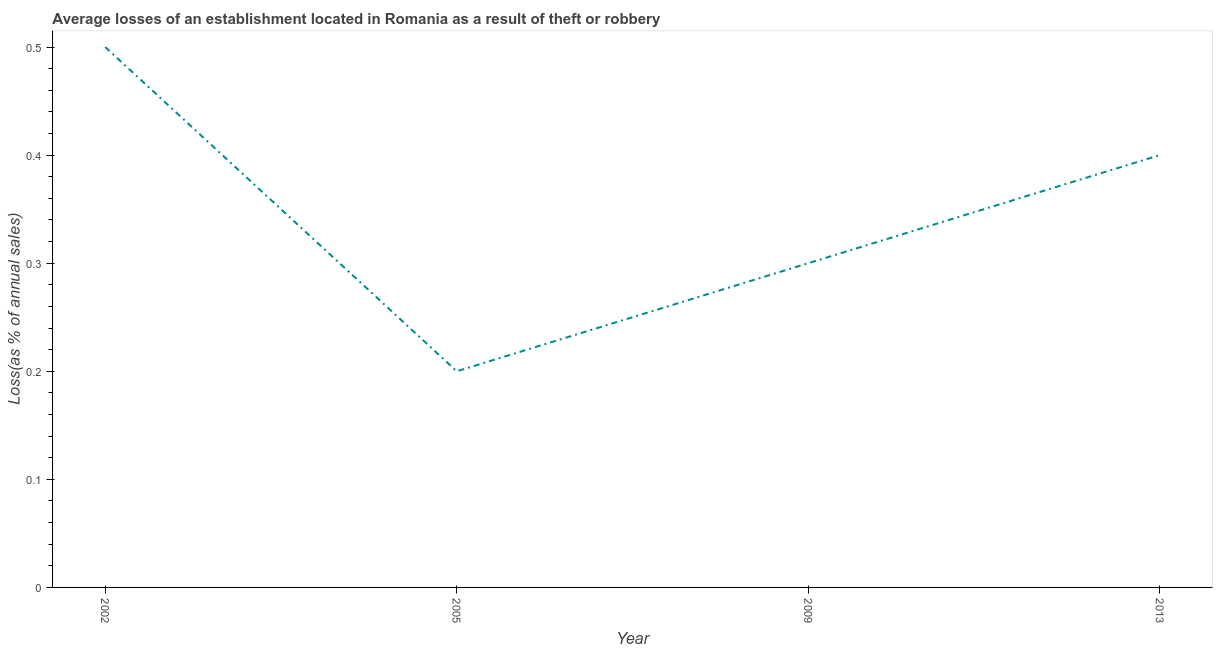In which year was the losses due to theft maximum?
Your answer should be compact. 2002. In which year was the losses due to theft minimum?
Your answer should be very brief. 2005. What is the difference between the losses due to theft in 2002 and 2005?
Your answer should be compact. 0.3. What is the average losses due to theft per year?
Provide a short and direct response. 0.35. What is the median losses due to theft?
Your answer should be very brief. 0.35. Do a majority of the years between 2009 and 2002 (inclusive) have losses due to theft greater than 0.44 %?
Your answer should be compact. No. What is the ratio of the losses due to theft in 2005 to that in 2013?
Your response must be concise. 0.5. What is the difference between the highest and the second highest losses due to theft?
Keep it short and to the point. 0.1. What is the difference between the highest and the lowest losses due to theft?
Offer a terse response. 0.3. In how many years, is the losses due to theft greater than the average losses due to theft taken over all years?
Make the answer very short. 2. Does the losses due to theft monotonically increase over the years?
Your answer should be compact. No. How many lines are there?
Your answer should be very brief. 1. How many years are there in the graph?
Your response must be concise. 4. Are the values on the major ticks of Y-axis written in scientific E-notation?
Ensure brevity in your answer.  No. Does the graph contain any zero values?
Make the answer very short. No. What is the title of the graph?
Give a very brief answer. Average losses of an establishment located in Romania as a result of theft or robbery. What is the label or title of the X-axis?
Make the answer very short. Year. What is the label or title of the Y-axis?
Make the answer very short. Loss(as % of annual sales). What is the Loss(as % of annual sales) of 2009?
Give a very brief answer. 0.3. What is the difference between the Loss(as % of annual sales) in 2002 and 2013?
Give a very brief answer. 0.1. What is the difference between the Loss(as % of annual sales) in 2005 and 2009?
Provide a succinct answer. -0.1. What is the difference between the Loss(as % of annual sales) in 2009 and 2013?
Keep it short and to the point. -0.1. What is the ratio of the Loss(as % of annual sales) in 2002 to that in 2005?
Provide a short and direct response. 2.5. What is the ratio of the Loss(as % of annual sales) in 2002 to that in 2009?
Ensure brevity in your answer.  1.67. What is the ratio of the Loss(as % of annual sales) in 2005 to that in 2009?
Give a very brief answer. 0.67. What is the ratio of the Loss(as % of annual sales) in 2005 to that in 2013?
Keep it short and to the point. 0.5. What is the ratio of the Loss(as % of annual sales) in 2009 to that in 2013?
Make the answer very short. 0.75. 